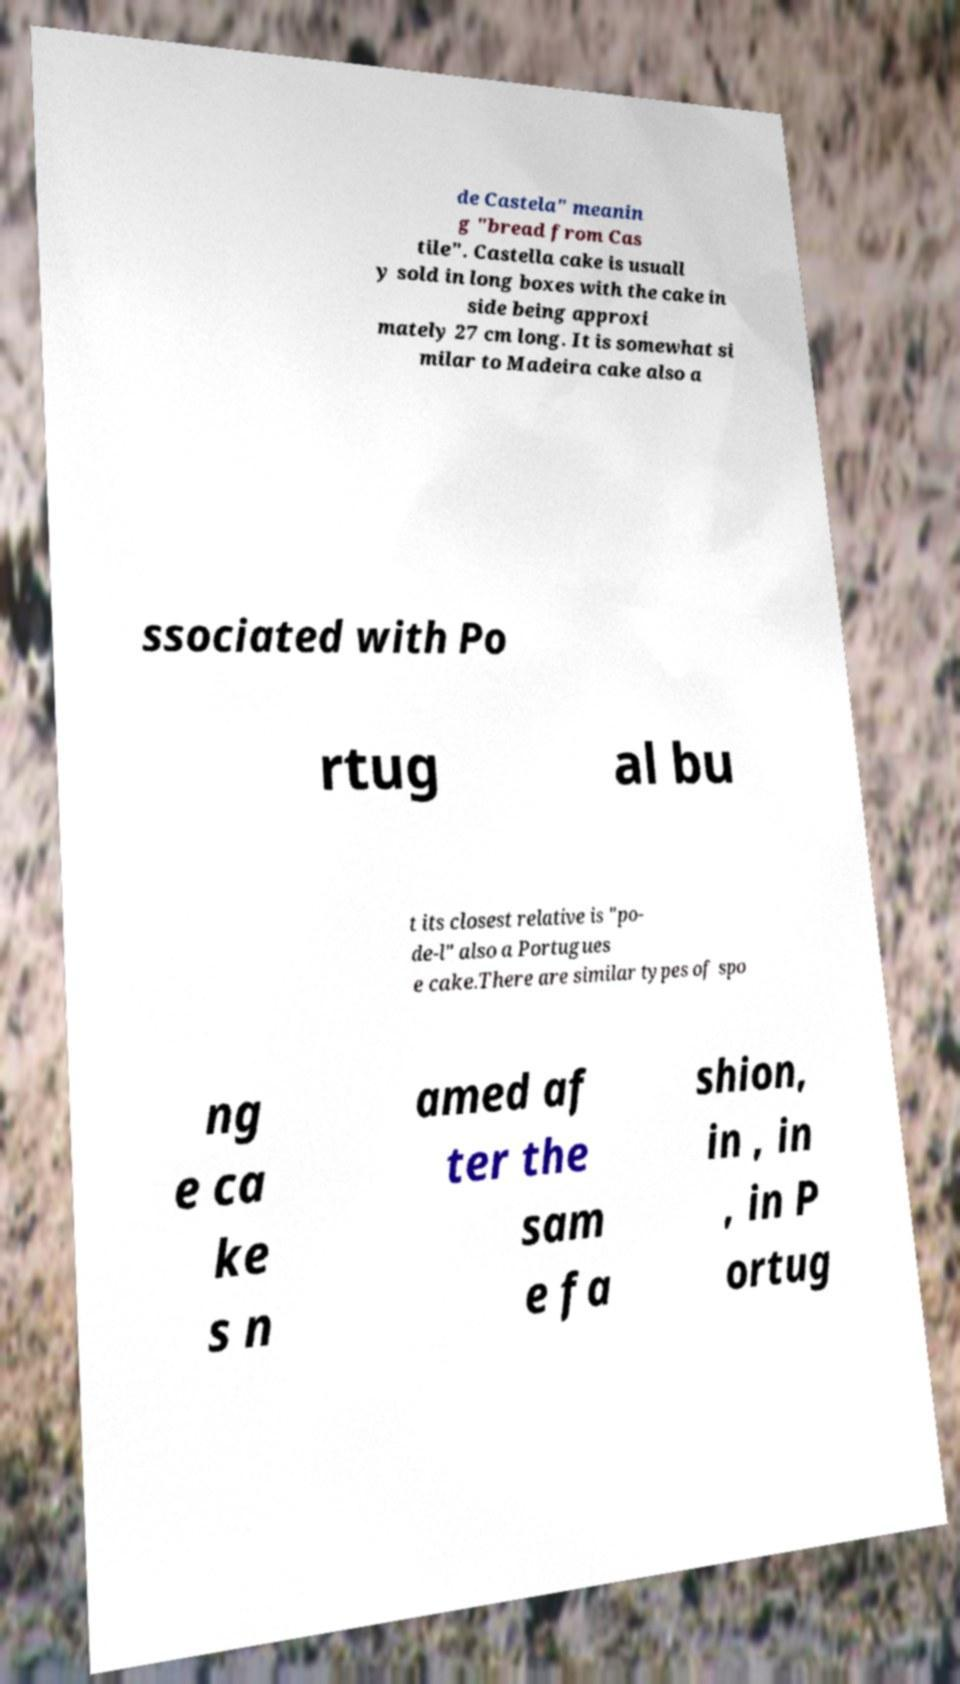Can you read and provide the text displayed in the image?This photo seems to have some interesting text. Can you extract and type it out for me? de Castela" meanin g "bread from Cas tile". Castella cake is usuall y sold in long boxes with the cake in side being approxi mately 27 cm long. It is somewhat si milar to Madeira cake also a ssociated with Po rtug al bu t its closest relative is "po- de-l" also a Portugues e cake.There are similar types of spo ng e ca ke s n amed af ter the sam e fa shion, in , in , in P ortug 